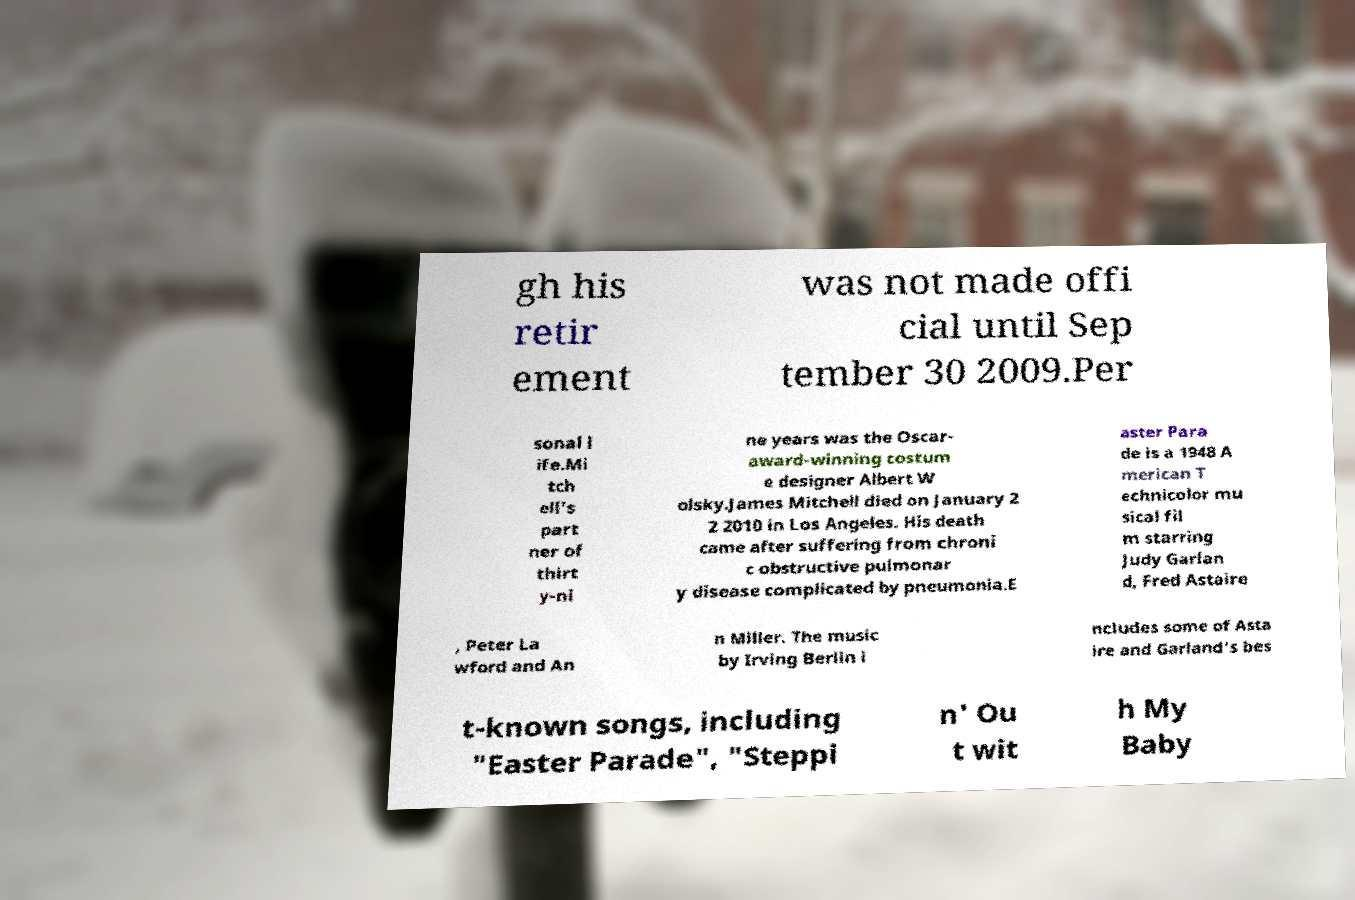Can you read and provide the text displayed in the image?This photo seems to have some interesting text. Can you extract and type it out for me? gh his retir ement was not made offi cial until Sep tember 30 2009.Per sonal l ife.Mi tch ell's part ner of thirt y-ni ne years was the Oscar- award-winning costum e designer Albert W olsky.James Mitchell died on January 2 2 2010 in Los Angeles. His death came after suffering from chroni c obstructive pulmonar y disease complicated by pneumonia.E aster Para de is a 1948 A merican T echnicolor mu sical fil m starring Judy Garlan d, Fred Astaire , Peter La wford and An n Miller. The music by Irving Berlin i ncludes some of Asta ire and Garland's bes t-known songs, including "Easter Parade", "Steppi n' Ou t wit h My Baby 